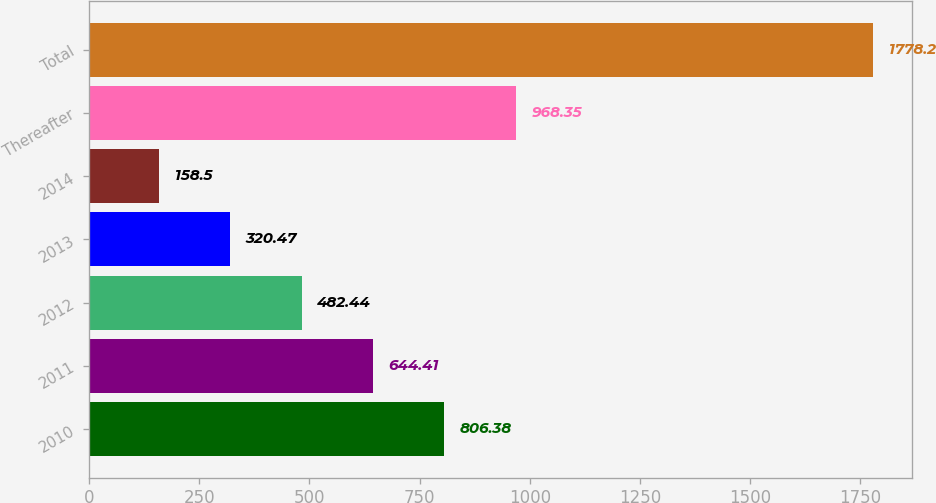Convert chart. <chart><loc_0><loc_0><loc_500><loc_500><bar_chart><fcel>2010<fcel>2011<fcel>2012<fcel>2013<fcel>2014<fcel>Thereafter<fcel>Total<nl><fcel>806.38<fcel>644.41<fcel>482.44<fcel>320.47<fcel>158.5<fcel>968.35<fcel>1778.2<nl></chart> 